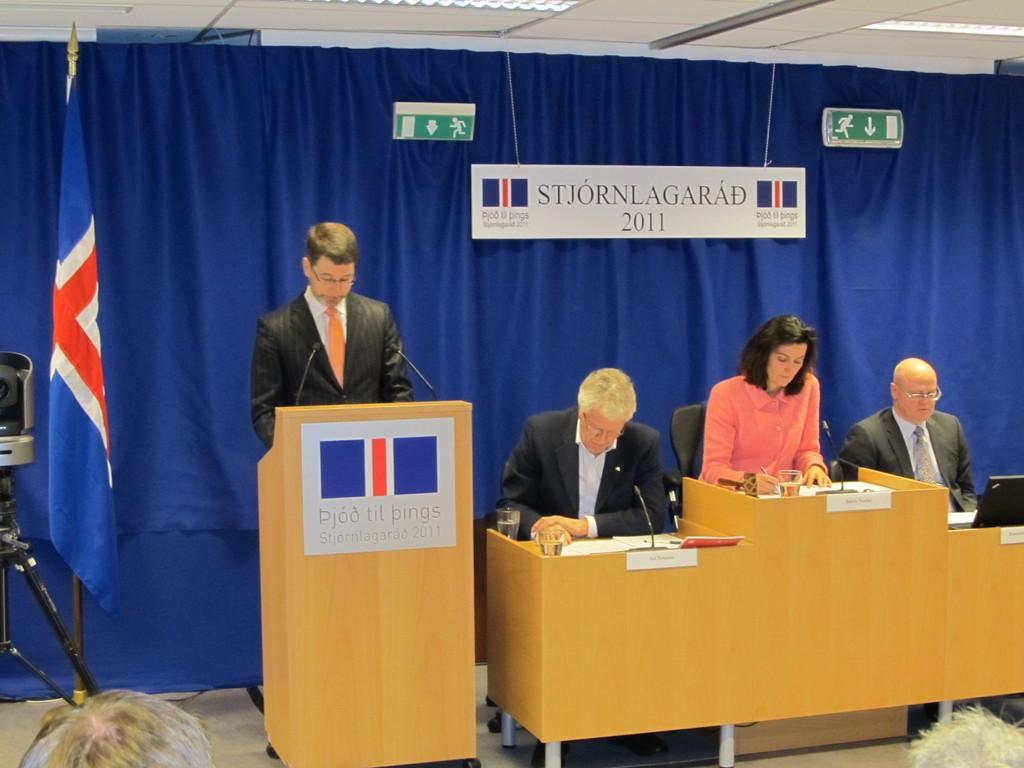<image>
Render a clear and concise summary of the photo. a group of speakers with signage saying STJORNLAGARAD 2011 in back of them and on the higher speaker stand as well. 